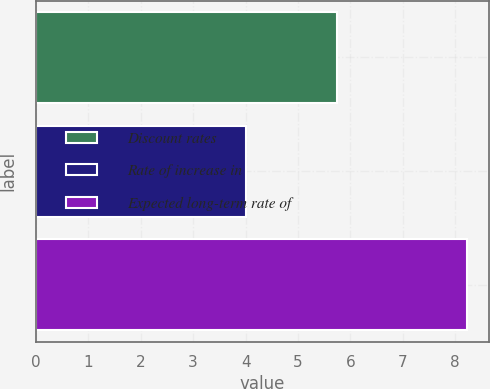Convert chart to OTSL. <chart><loc_0><loc_0><loc_500><loc_500><bar_chart><fcel>Discount rates<fcel>Rate of increase in<fcel>Expected long-term rate of<nl><fcel>5.75<fcel>4<fcel>8.23<nl></chart> 